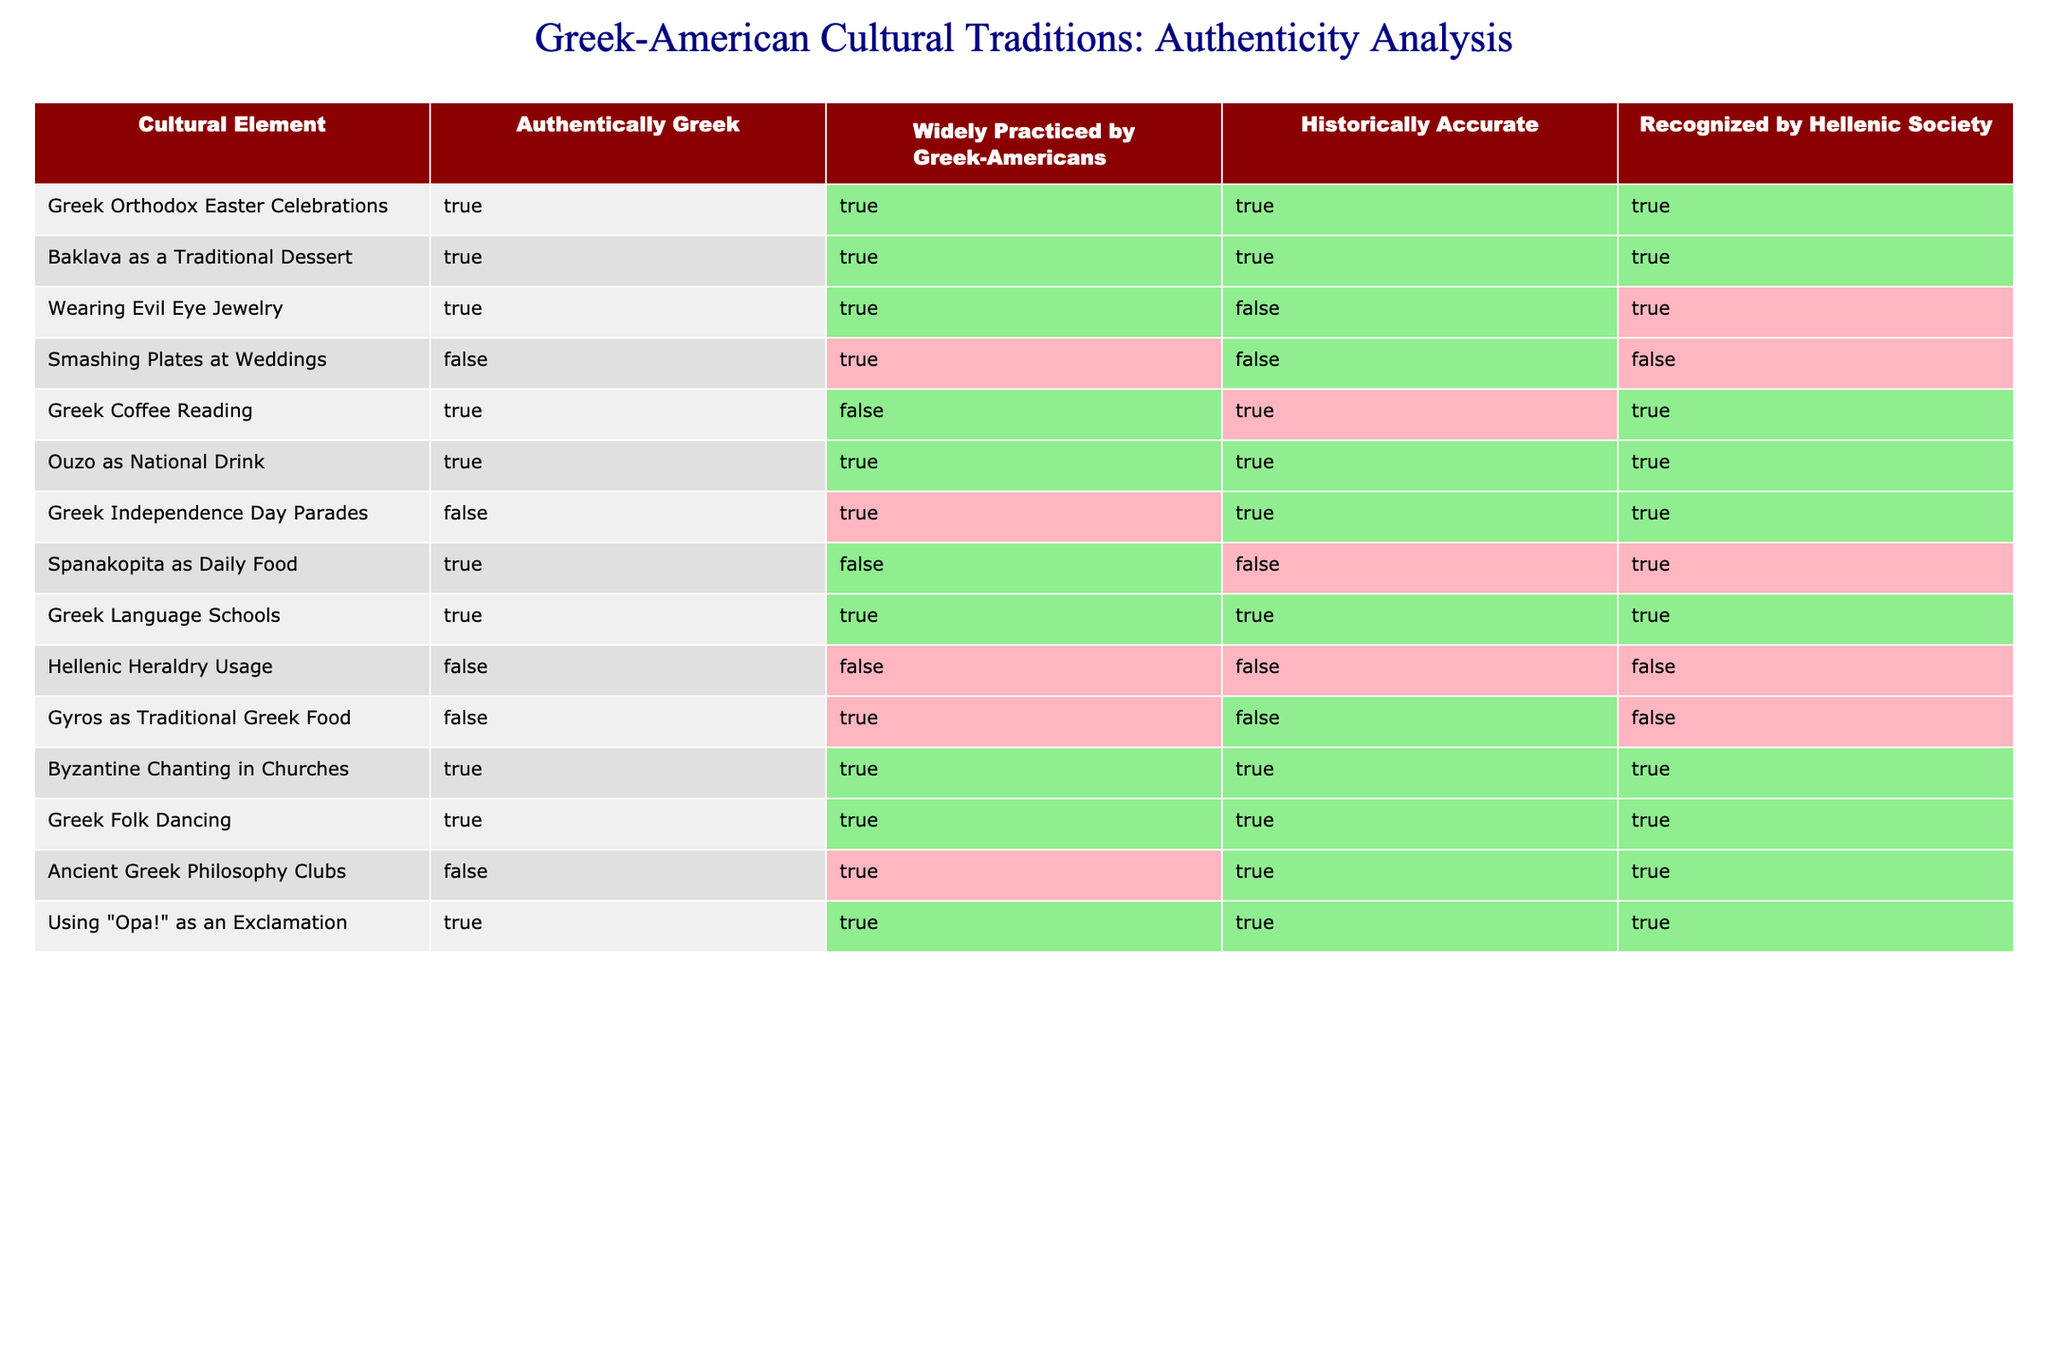What proportion of cultural elements are both authentically Greek and widely practiced by Greek-Americans? There are 14 cultural elements in total. The ones that are both authentically Greek and widely practiced are: Greek Orthodox Easter Celebrations, Baklava as a Traditional Dessert, Wearing Evil Eye Jewelry, Ouzo as National Drink, Greek Language Schools, Byzantine Chanting in Churches, Greek Folk Dancing, and Using "Opa!" as an Exclamation, which totals to 8 elements. The proportion is therefore 8/14 = 0.571 or approximately 57.1%.
Answer: Approximately 57.1% How many cultural elements are recognized by the Hellenic Society but are not historically accurate? In the table, the cultural elements that are recognized by the Hellenic Society are: Wearing Evil Eye Jewelry, Greek Independence Day Parades, Spanakopita as Daily Food, Greek Language Schools, Byzantine Chanting in Churches, Greek Folk Dancing, Ancient Greek Philosophy Clubs, and Using "Opa!" as an Exclamation, totaling 8. Among these, only Wearing Evil Eye Jewelry and Spanakopita as Daily Food are not historically accurate. Therefore, the count is 2.
Answer: 2 Is Greek Folk Dancing both authentically Greek and historically accurate? According to the table, Greek Folk Dancing is marked as true for both 'Authentically Greek' and 'Historically Accurate.' Thus, we can confirm that Greek Folk Dancing meets both criteria.
Answer: Yes Which cultural element has the highest number of criteria marked as true? To find the cultural element with the most criteria marked as true, we can tally the true counts for each element. The cultural elements that meet all four criteria are: Greek Orthodox Easter Celebrations, Baklava as a Traditional Dessert, Ouzo as National Drink, Greek Language Schools, Byzantine Chanting in Churches, Greek Folk Dancing, and Using "Opa!" as an Exclamation. Each has 4 true marks. Therefore, multiple elements have the highest counts.
Answer: Multiple elements (7) What is the percentage of elements that are both historically accurate and recognized by the Hellenic Society? There are 14 cultural elements in total. The elements that are both historically accurate and recognized by the Hellenic Society are: Greek Orthodox Easter Celebrations, Baklava as a Traditional Dessert, Greek Independence Day Parades, Greek Language Schools, Byzantine Chanting in Churches, Greek Folk Dancing, and Using "Opa!" as an Exclamation, totaling 7. The percentage is thus (7/14) * 100 = 50%.
Answer: 50% 